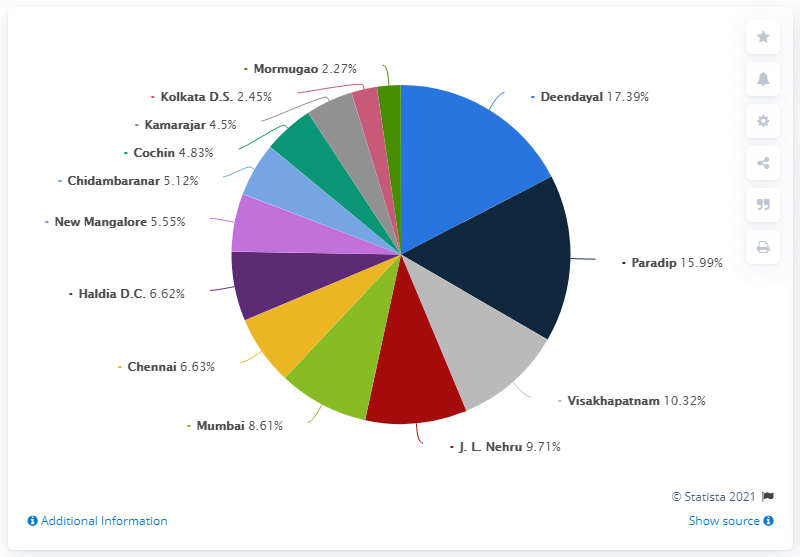Highlight a few significant elements in this photo. The sum value of Paradip and J.L. Nehru is 25.7. In the fiscal year 2020, the Deendayal port in India handled a total of 17.39% of the total cargo handled in the country. The color of the pie segment in Mumbai is green. 